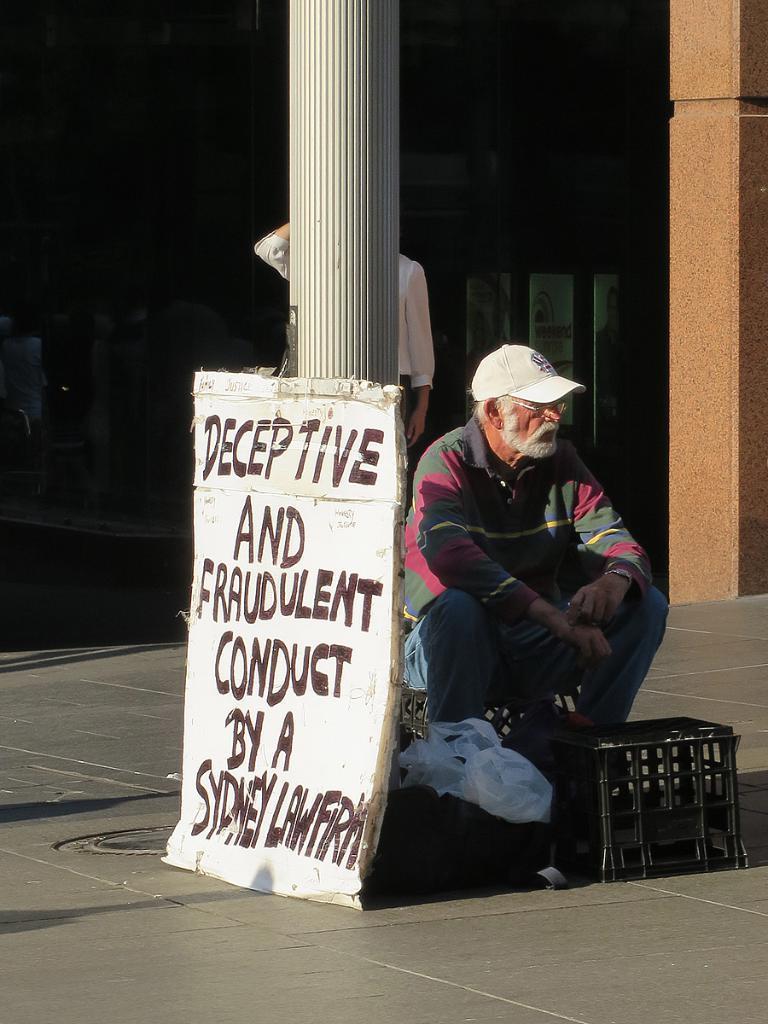Describe this image in one or two sentences. In this image, a man is sitting and wearing cap and glasses. Here we can see few carry bags, stool, name board and pillar. Behind the pillar we can see a human. Background we can see glass doors, wall. Here we can see a footpath. 